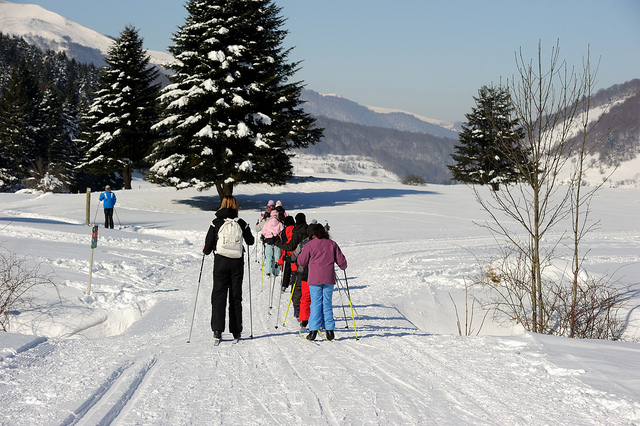<image>How many women are going to ski? It is uncertain how many women are going to ski. How many women are going to ski? It is ambiguous how many women are going to ski. It can be seen 3, 4, 6, 7, 9, or 11 women. 